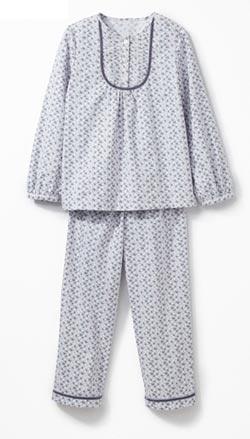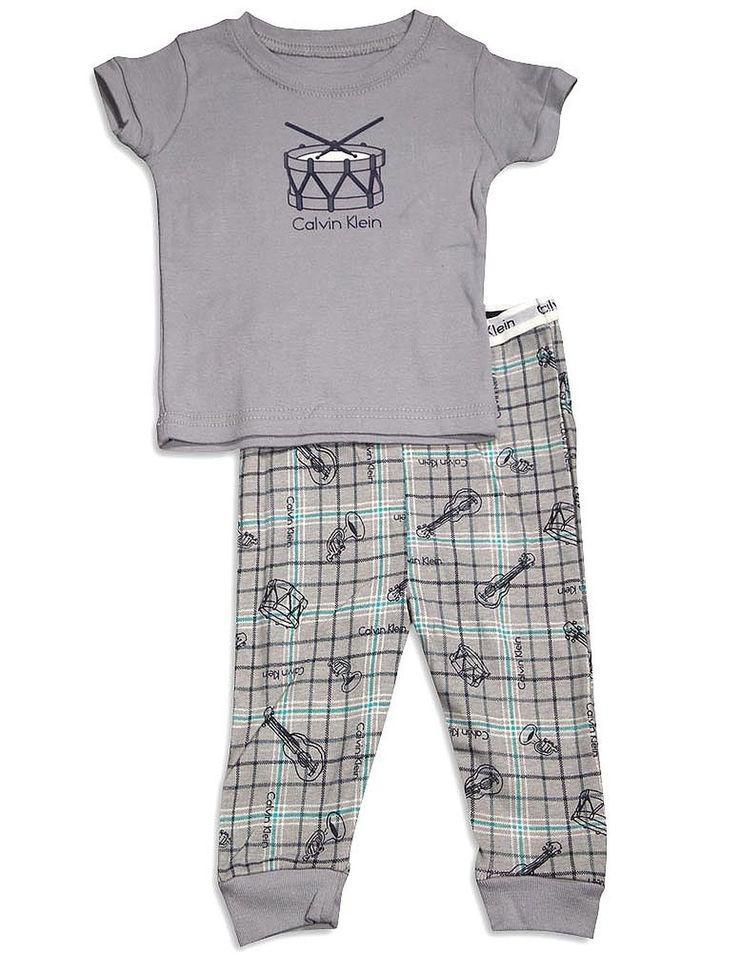The first image is the image on the left, the second image is the image on the right. Evaluate the accuracy of this statement regarding the images: "At least one of the outfits features an animal-themed design.". Is it true? Answer yes or no. No. The first image is the image on the left, the second image is the image on the right. For the images shown, is this caption "There is one outfit containing two articles of clothing per image." true? Answer yes or no. Yes. 